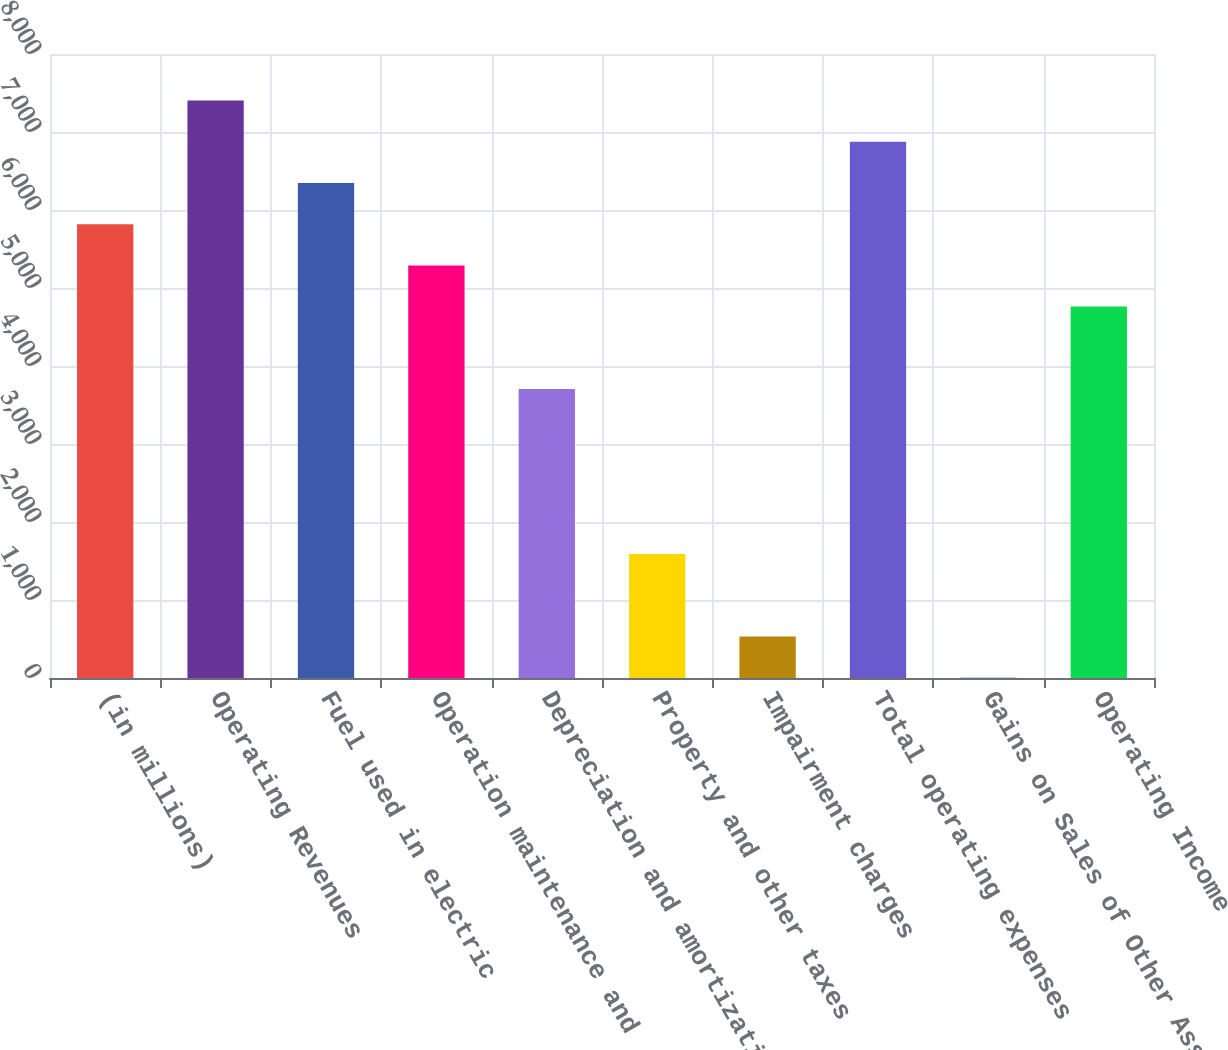Convert chart. <chart><loc_0><loc_0><loc_500><loc_500><bar_chart><fcel>(in millions)<fcel>Operating Revenues<fcel>Fuel used in electric<fcel>Operation maintenance and<fcel>Depreciation and amortization<fcel>Property and other taxes<fcel>Impairment charges<fcel>Total operating expenses<fcel>Gains on Sales of Other Assets<fcel>Operating Income<nl><fcel>5818.7<fcel>7404.8<fcel>6347.4<fcel>5290<fcel>3703.9<fcel>1589.1<fcel>531.7<fcel>6876.1<fcel>3<fcel>4761.3<nl></chart> 